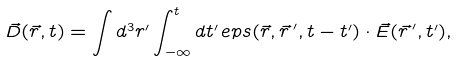Convert formula to latex. <formula><loc_0><loc_0><loc_500><loc_500>\vec { D } ( \vec { r } , t ) = \int d ^ { 3 } r ^ { \prime } \int _ { - \infty } ^ { t } d t ^ { \prime } \, e p s ( \vec { r } , \vec { r \, } ^ { \prime } , t - t ^ { \prime } ) \cdot \vec { E } ( \vec { r \, } ^ { \prime } , t ^ { \prime } ) ,</formula> 